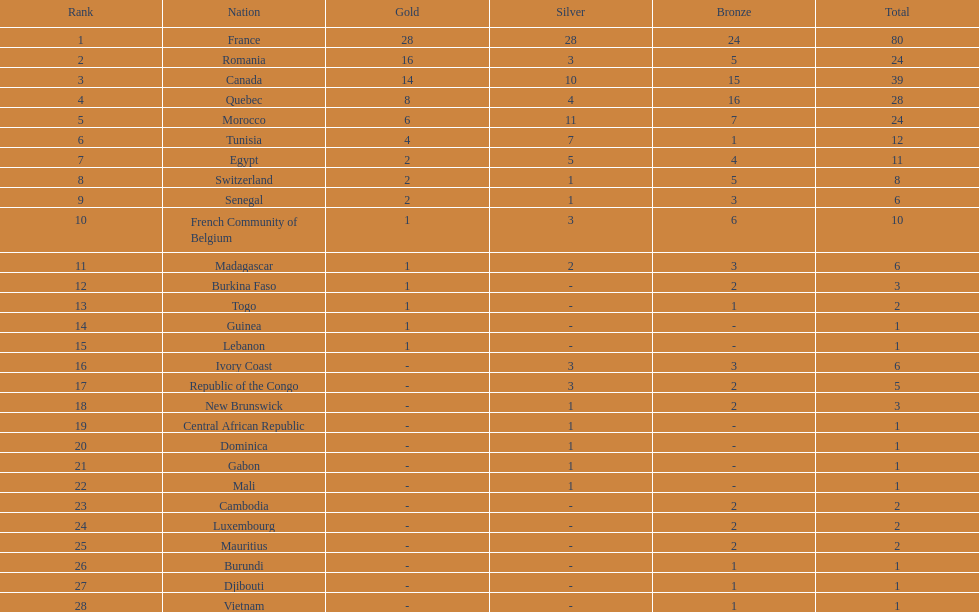Who placed in first according to medals? France. 